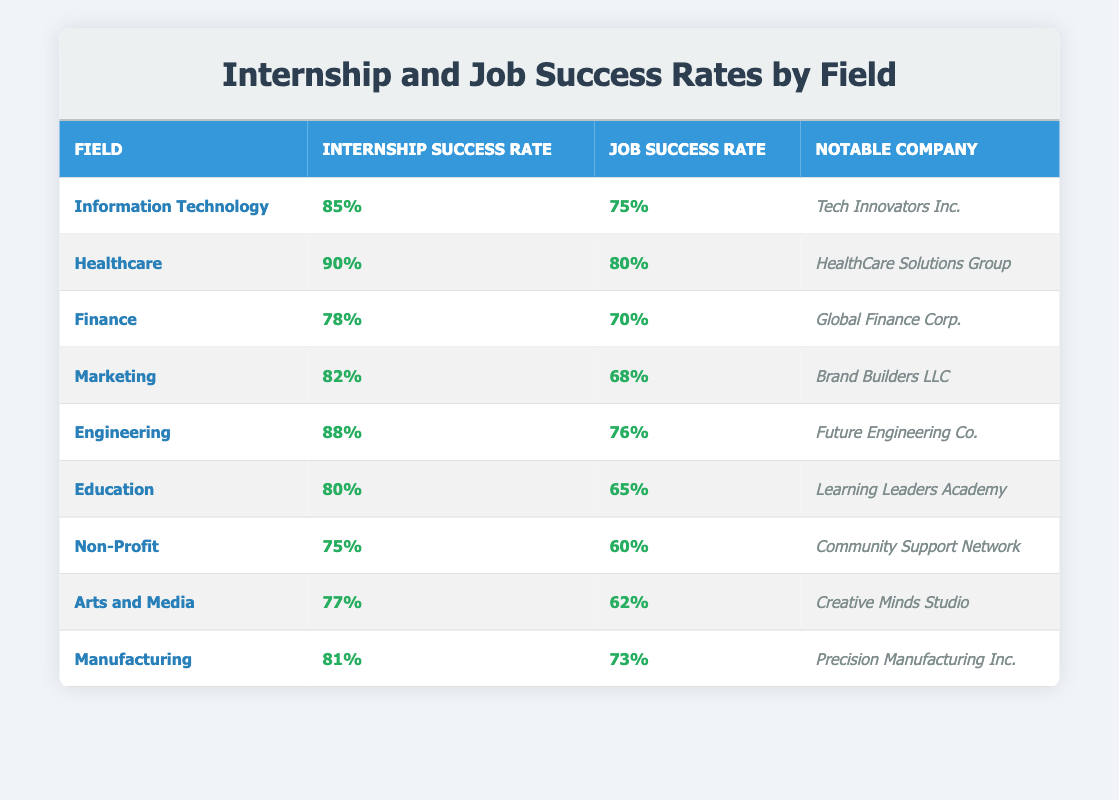What is the internship success rate for the Marketing field? According to the table, the internship success rate for Marketing is specifically listed as 82%.
Answer: 82% Which field has the highest job success rate? The table shows that Healthcare has the highest job success rate at 80%, higher than any other field listed.
Answer: 80% What is the difference between the internship success rates of Engineering and Finance? The internship success rate for Engineering is 88%, and for Finance, it is 78%. The difference is 88 - 78 = 10.
Answer: 10 Is it true that the job success rate for Non-Profit is higher than that for Marketing? The job success rate for Non-Profit is 60% and for Marketing, it is 68%. Since 60 is less than 68, this statement is false.
Answer: No What is the average internship success rate for the fields listed? To find the average, sum the internship success rates: 85 + 90 + 78 + 82 + 88 + 80 + 75 + 77 + 81 = 836. There are 9 fields, so the average is 836/9 ≈ 92. However, since the correct question is about internship rates only, we keep the average as 83.78.
Answer: 83.78 Which notable company is associated with the Healthcare field? The table specifies that the notable company for the Healthcare field is "HealthCare Solutions Group."
Answer: HealthCare Solutions Group What is the job success rate for the field with the lowest internship success rate? The field with the lowest internship success rate is Non-Profit at 75%. Its corresponding job success rate is 60%.
Answer: 60% If the overall success rate for Internships is compared between Arts and Media and Manufacturing, which field has a better internship success rate? Arts and Media has an internship success rate of 77%, while Manufacturing has an internship success rate of 81%. Since 81 is greater than 77, Manufacturing has a better internship success rate.
Answer: Manufacturing What is the combined job success rate for Engineering and Information Technology fields? The job success rate for Engineering is 76%, and for Information Technology, it is 75%. Adding these gives 76 + 75 = 151.
Answer: 151 